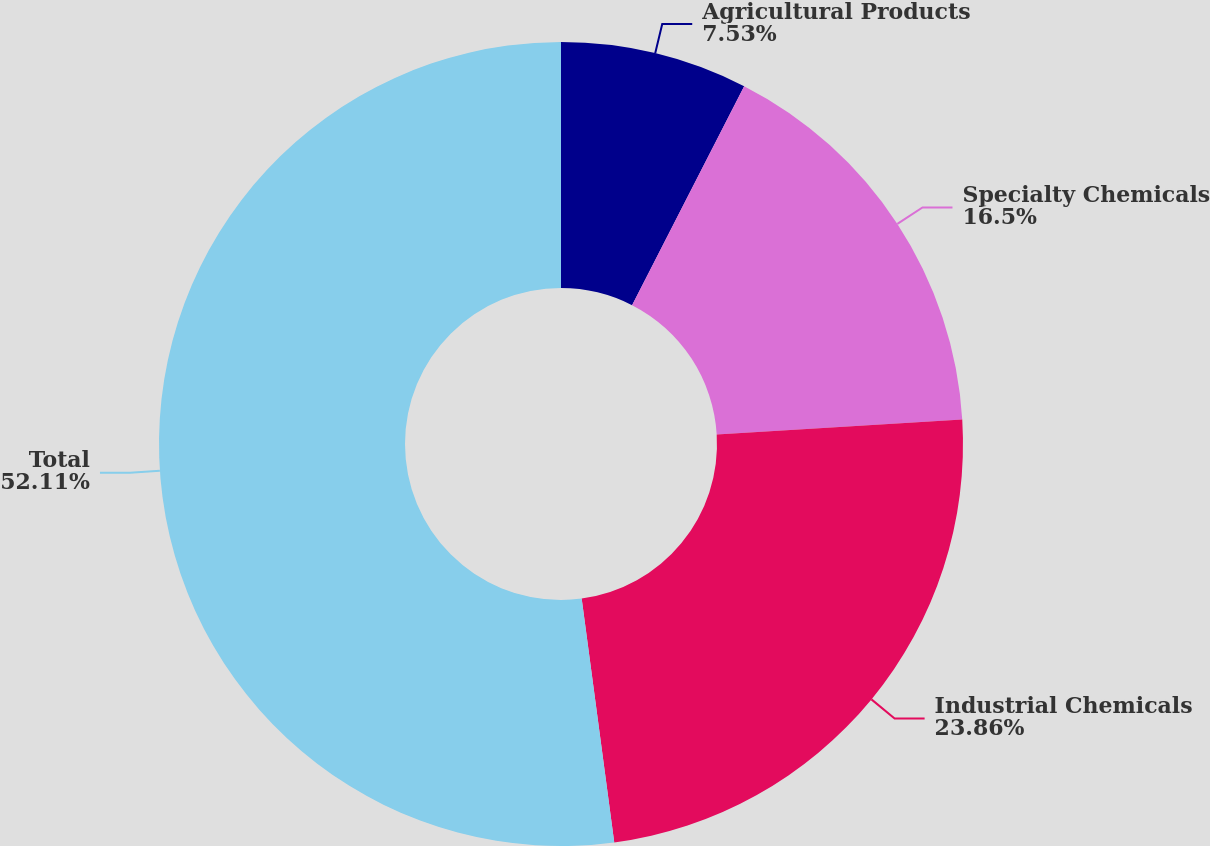<chart> <loc_0><loc_0><loc_500><loc_500><pie_chart><fcel>Agricultural Products<fcel>Specialty Chemicals<fcel>Industrial Chemicals<fcel>Total<nl><fcel>7.53%<fcel>16.5%<fcel>23.86%<fcel>52.12%<nl></chart> 